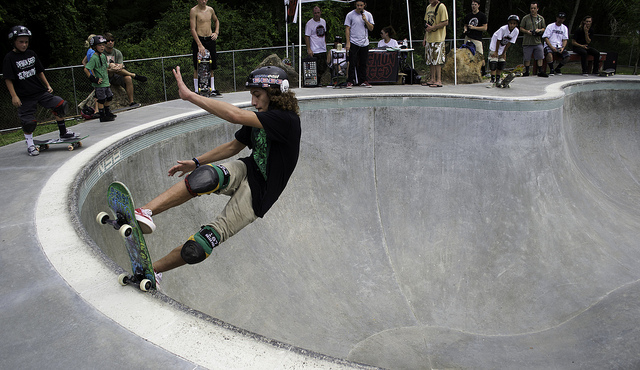What does the presence of onlookers tell us about this skateboarding scene? The onlookers' presence indicates a social aspect to skateboarding culture, where community and peer recognition play a significant role in the enjoyment and sharing of the sport. 